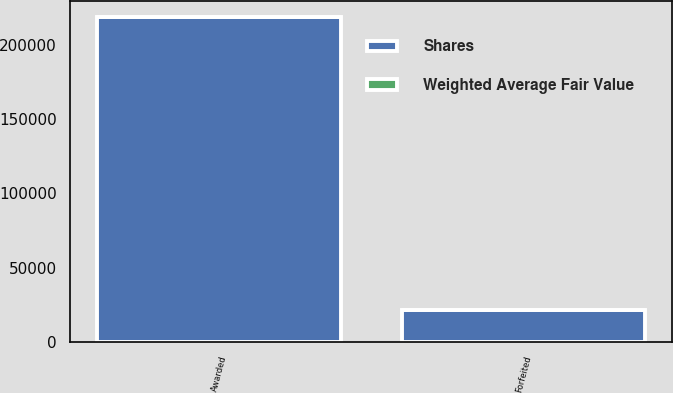Convert chart to OTSL. <chart><loc_0><loc_0><loc_500><loc_500><stacked_bar_chart><ecel><fcel>Awarded<fcel>Forfeited<nl><fcel>Shares<fcel>218273<fcel>21354<nl><fcel>Weighted Average Fair Value<fcel>80.24<fcel>55.41<nl></chart> 